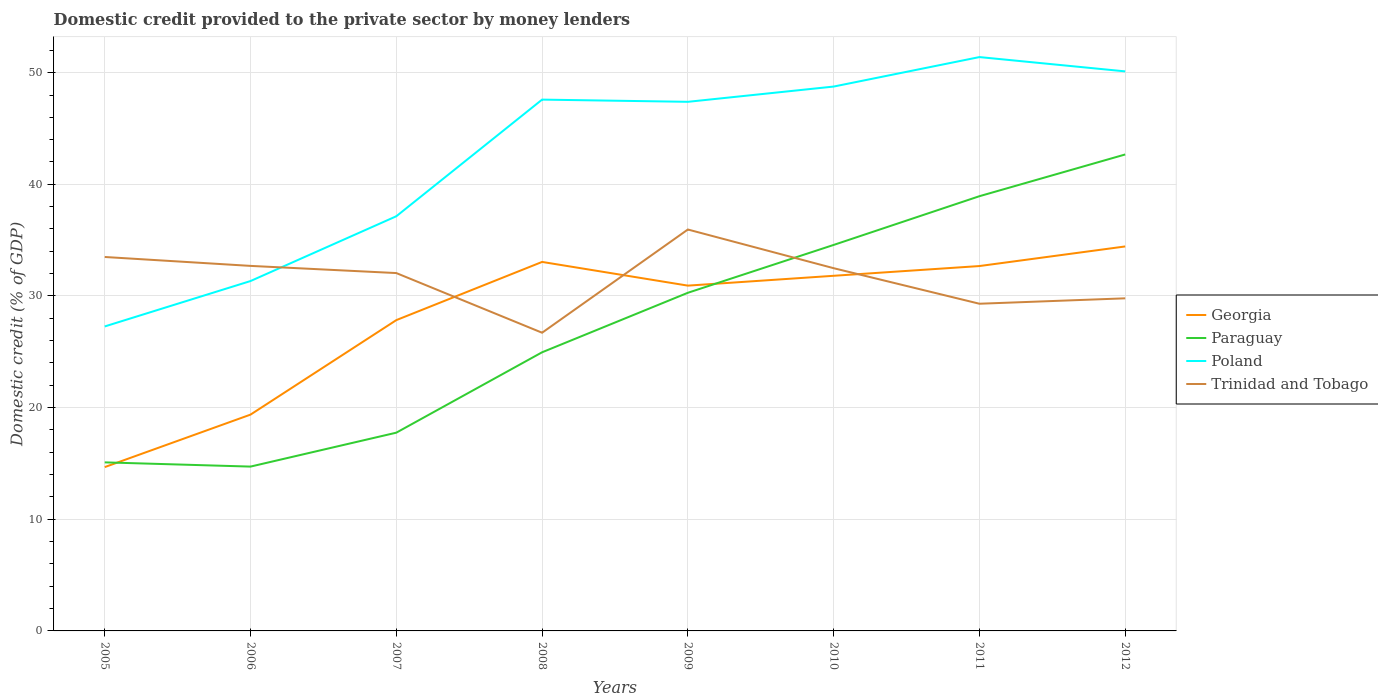How many different coloured lines are there?
Keep it short and to the point. 4. Does the line corresponding to Poland intersect with the line corresponding to Paraguay?
Provide a succinct answer. No. Across all years, what is the maximum domestic credit provided to the private sector by money lenders in Poland?
Make the answer very short. 27.27. In which year was the domestic credit provided to the private sector by money lenders in Georgia maximum?
Ensure brevity in your answer.  2005. What is the total domestic credit provided to the private sector by money lenders in Paraguay in the graph?
Your answer should be compact. -4.29. What is the difference between the highest and the second highest domestic credit provided to the private sector by money lenders in Trinidad and Tobago?
Ensure brevity in your answer.  9.25. Is the domestic credit provided to the private sector by money lenders in Poland strictly greater than the domestic credit provided to the private sector by money lenders in Trinidad and Tobago over the years?
Make the answer very short. No. How many lines are there?
Offer a very short reply. 4. Does the graph contain any zero values?
Ensure brevity in your answer.  No. How are the legend labels stacked?
Ensure brevity in your answer.  Vertical. What is the title of the graph?
Provide a succinct answer. Domestic credit provided to the private sector by money lenders. Does "Dominican Republic" appear as one of the legend labels in the graph?
Ensure brevity in your answer.  No. What is the label or title of the Y-axis?
Ensure brevity in your answer.  Domestic credit (% of GDP). What is the Domestic credit (% of GDP) of Georgia in 2005?
Provide a short and direct response. 14.67. What is the Domestic credit (% of GDP) of Paraguay in 2005?
Your answer should be compact. 15.1. What is the Domestic credit (% of GDP) of Poland in 2005?
Provide a succinct answer. 27.27. What is the Domestic credit (% of GDP) in Trinidad and Tobago in 2005?
Make the answer very short. 33.49. What is the Domestic credit (% of GDP) of Georgia in 2006?
Offer a very short reply. 19.37. What is the Domestic credit (% of GDP) of Paraguay in 2006?
Make the answer very short. 14.72. What is the Domestic credit (% of GDP) in Poland in 2006?
Offer a terse response. 31.34. What is the Domestic credit (% of GDP) of Trinidad and Tobago in 2006?
Provide a short and direct response. 32.7. What is the Domestic credit (% of GDP) in Georgia in 2007?
Make the answer very short. 27.84. What is the Domestic credit (% of GDP) in Paraguay in 2007?
Provide a short and direct response. 17.76. What is the Domestic credit (% of GDP) of Poland in 2007?
Give a very brief answer. 37.14. What is the Domestic credit (% of GDP) of Trinidad and Tobago in 2007?
Your answer should be compact. 32.05. What is the Domestic credit (% of GDP) of Georgia in 2008?
Ensure brevity in your answer.  33.05. What is the Domestic credit (% of GDP) in Paraguay in 2008?
Your response must be concise. 24.96. What is the Domestic credit (% of GDP) in Poland in 2008?
Offer a very short reply. 47.59. What is the Domestic credit (% of GDP) of Trinidad and Tobago in 2008?
Provide a succinct answer. 26.71. What is the Domestic credit (% of GDP) of Georgia in 2009?
Keep it short and to the point. 30.93. What is the Domestic credit (% of GDP) of Paraguay in 2009?
Make the answer very short. 30.29. What is the Domestic credit (% of GDP) of Poland in 2009?
Keep it short and to the point. 47.39. What is the Domestic credit (% of GDP) of Trinidad and Tobago in 2009?
Your answer should be very brief. 35.95. What is the Domestic credit (% of GDP) in Georgia in 2010?
Provide a short and direct response. 31.81. What is the Domestic credit (% of GDP) in Paraguay in 2010?
Give a very brief answer. 34.57. What is the Domestic credit (% of GDP) in Poland in 2010?
Give a very brief answer. 48.76. What is the Domestic credit (% of GDP) of Trinidad and Tobago in 2010?
Your response must be concise. 32.49. What is the Domestic credit (% of GDP) of Georgia in 2011?
Give a very brief answer. 32.68. What is the Domestic credit (% of GDP) in Paraguay in 2011?
Provide a short and direct response. 38.94. What is the Domestic credit (% of GDP) in Poland in 2011?
Give a very brief answer. 51.4. What is the Domestic credit (% of GDP) of Trinidad and Tobago in 2011?
Give a very brief answer. 29.3. What is the Domestic credit (% of GDP) of Georgia in 2012?
Offer a terse response. 34.44. What is the Domestic credit (% of GDP) in Paraguay in 2012?
Your answer should be compact. 42.68. What is the Domestic credit (% of GDP) of Poland in 2012?
Provide a succinct answer. 50.12. What is the Domestic credit (% of GDP) in Trinidad and Tobago in 2012?
Offer a terse response. 29.79. Across all years, what is the maximum Domestic credit (% of GDP) of Georgia?
Your answer should be compact. 34.44. Across all years, what is the maximum Domestic credit (% of GDP) of Paraguay?
Your answer should be very brief. 42.68. Across all years, what is the maximum Domestic credit (% of GDP) of Poland?
Make the answer very short. 51.4. Across all years, what is the maximum Domestic credit (% of GDP) of Trinidad and Tobago?
Provide a short and direct response. 35.95. Across all years, what is the minimum Domestic credit (% of GDP) in Georgia?
Give a very brief answer. 14.67. Across all years, what is the minimum Domestic credit (% of GDP) in Paraguay?
Provide a short and direct response. 14.72. Across all years, what is the minimum Domestic credit (% of GDP) in Poland?
Offer a terse response. 27.27. Across all years, what is the minimum Domestic credit (% of GDP) in Trinidad and Tobago?
Offer a terse response. 26.71. What is the total Domestic credit (% of GDP) of Georgia in the graph?
Your response must be concise. 224.79. What is the total Domestic credit (% of GDP) in Paraguay in the graph?
Your answer should be compact. 219. What is the total Domestic credit (% of GDP) of Poland in the graph?
Provide a succinct answer. 341. What is the total Domestic credit (% of GDP) in Trinidad and Tobago in the graph?
Make the answer very short. 252.48. What is the difference between the Domestic credit (% of GDP) of Georgia in 2005 and that in 2006?
Your response must be concise. -4.7. What is the difference between the Domestic credit (% of GDP) in Paraguay in 2005 and that in 2006?
Offer a very short reply. 0.38. What is the difference between the Domestic credit (% of GDP) of Poland in 2005 and that in 2006?
Give a very brief answer. -4.07. What is the difference between the Domestic credit (% of GDP) of Trinidad and Tobago in 2005 and that in 2006?
Your answer should be very brief. 0.8. What is the difference between the Domestic credit (% of GDP) of Georgia in 2005 and that in 2007?
Provide a short and direct response. -13.16. What is the difference between the Domestic credit (% of GDP) in Paraguay in 2005 and that in 2007?
Give a very brief answer. -2.66. What is the difference between the Domestic credit (% of GDP) of Poland in 2005 and that in 2007?
Give a very brief answer. -9.87. What is the difference between the Domestic credit (% of GDP) of Trinidad and Tobago in 2005 and that in 2007?
Provide a succinct answer. 1.44. What is the difference between the Domestic credit (% of GDP) of Georgia in 2005 and that in 2008?
Keep it short and to the point. -18.38. What is the difference between the Domestic credit (% of GDP) of Paraguay in 2005 and that in 2008?
Ensure brevity in your answer.  -9.86. What is the difference between the Domestic credit (% of GDP) of Poland in 2005 and that in 2008?
Offer a terse response. -20.32. What is the difference between the Domestic credit (% of GDP) of Trinidad and Tobago in 2005 and that in 2008?
Your answer should be very brief. 6.78. What is the difference between the Domestic credit (% of GDP) of Georgia in 2005 and that in 2009?
Your response must be concise. -16.25. What is the difference between the Domestic credit (% of GDP) in Paraguay in 2005 and that in 2009?
Keep it short and to the point. -15.19. What is the difference between the Domestic credit (% of GDP) of Poland in 2005 and that in 2009?
Ensure brevity in your answer.  -20.12. What is the difference between the Domestic credit (% of GDP) of Trinidad and Tobago in 2005 and that in 2009?
Provide a short and direct response. -2.46. What is the difference between the Domestic credit (% of GDP) of Georgia in 2005 and that in 2010?
Offer a very short reply. -17.13. What is the difference between the Domestic credit (% of GDP) in Paraguay in 2005 and that in 2010?
Offer a very short reply. -19.48. What is the difference between the Domestic credit (% of GDP) in Poland in 2005 and that in 2010?
Make the answer very short. -21.49. What is the difference between the Domestic credit (% of GDP) in Trinidad and Tobago in 2005 and that in 2010?
Offer a very short reply. 1. What is the difference between the Domestic credit (% of GDP) in Georgia in 2005 and that in 2011?
Your answer should be compact. -18.01. What is the difference between the Domestic credit (% of GDP) in Paraguay in 2005 and that in 2011?
Provide a short and direct response. -23.84. What is the difference between the Domestic credit (% of GDP) in Poland in 2005 and that in 2011?
Make the answer very short. -24.13. What is the difference between the Domestic credit (% of GDP) in Trinidad and Tobago in 2005 and that in 2011?
Make the answer very short. 4.19. What is the difference between the Domestic credit (% of GDP) in Georgia in 2005 and that in 2012?
Provide a short and direct response. -19.76. What is the difference between the Domestic credit (% of GDP) of Paraguay in 2005 and that in 2012?
Your answer should be compact. -27.58. What is the difference between the Domestic credit (% of GDP) of Poland in 2005 and that in 2012?
Your answer should be compact. -22.85. What is the difference between the Domestic credit (% of GDP) of Trinidad and Tobago in 2005 and that in 2012?
Your answer should be compact. 3.7. What is the difference between the Domestic credit (% of GDP) of Georgia in 2006 and that in 2007?
Offer a terse response. -8.46. What is the difference between the Domestic credit (% of GDP) of Paraguay in 2006 and that in 2007?
Your response must be concise. -3.04. What is the difference between the Domestic credit (% of GDP) in Poland in 2006 and that in 2007?
Your response must be concise. -5.8. What is the difference between the Domestic credit (% of GDP) of Trinidad and Tobago in 2006 and that in 2007?
Make the answer very short. 0.64. What is the difference between the Domestic credit (% of GDP) in Georgia in 2006 and that in 2008?
Offer a very short reply. -13.68. What is the difference between the Domestic credit (% of GDP) in Paraguay in 2006 and that in 2008?
Give a very brief answer. -10.24. What is the difference between the Domestic credit (% of GDP) of Poland in 2006 and that in 2008?
Make the answer very short. -16.25. What is the difference between the Domestic credit (% of GDP) in Trinidad and Tobago in 2006 and that in 2008?
Offer a terse response. 5.99. What is the difference between the Domestic credit (% of GDP) in Georgia in 2006 and that in 2009?
Provide a short and direct response. -11.55. What is the difference between the Domestic credit (% of GDP) of Paraguay in 2006 and that in 2009?
Your answer should be very brief. -15.57. What is the difference between the Domestic credit (% of GDP) of Poland in 2006 and that in 2009?
Give a very brief answer. -16.05. What is the difference between the Domestic credit (% of GDP) of Trinidad and Tobago in 2006 and that in 2009?
Ensure brevity in your answer.  -3.26. What is the difference between the Domestic credit (% of GDP) in Georgia in 2006 and that in 2010?
Provide a succinct answer. -12.43. What is the difference between the Domestic credit (% of GDP) of Paraguay in 2006 and that in 2010?
Your answer should be compact. -19.85. What is the difference between the Domestic credit (% of GDP) of Poland in 2006 and that in 2010?
Provide a short and direct response. -17.42. What is the difference between the Domestic credit (% of GDP) of Trinidad and Tobago in 2006 and that in 2010?
Make the answer very short. 0.21. What is the difference between the Domestic credit (% of GDP) in Georgia in 2006 and that in 2011?
Offer a very short reply. -13.31. What is the difference between the Domestic credit (% of GDP) of Paraguay in 2006 and that in 2011?
Offer a terse response. -24.22. What is the difference between the Domestic credit (% of GDP) of Poland in 2006 and that in 2011?
Provide a succinct answer. -20.06. What is the difference between the Domestic credit (% of GDP) in Trinidad and Tobago in 2006 and that in 2011?
Offer a very short reply. 3.39. What is the difference between the Domestic credit (% of GDP) of Georgia in 2006 and that in 2012?
Give a very brief answer. -15.06. What is the difference between the Domestic credit (% of GDP) in Paraguay in 2006 and that in 2012?
Your response must be concise. -27.96. What is the difference between the Domestic credit (% of GDP) in Poland in 2006 and that in 2012?
Your response must be concise. -18.78. What is the difference between the Domestic credit (% of GDP) of Trinidad and Tobago in 2006 and that in 2012?
Keep it short and to the point. 2.9. What is the difference between the Domestic credit (% of GDP) in Georgia in 2007 and that in 2008?
Make the answer very short. -5.21. What is the difference between the Domestic credit (% of GDP) of Paraguay in 2007 and that in 2008?
Keep it short and to the point. -7.2. What is the difference between the Domestic credit (% of GDP) of Poland in 2007 and that in 2008?
Make the answer very short. -10.45. What is the difference between the Domestic credit (% of GDP) of Trinidad and Tobago in 2007 and that in 2008?
Ensure brevity in your answer.  5.34. What is the difference between the Domestic credit (% of GDP) in Georgia in 2007 and that in 2009?
Offer a very short reply. -3.09. What is the difference between the Domestic credit (% of GDP) of Paraguay in 2007 and that in 2009?
Give a very brief answer. -12.53. What is the difference between the Domestic credit (% of GDP) in Poland in 2007 and that in 2009?
Provide a short and direct response. -10.25. What is the difference between the Domestic credit (% of GDP) of Trinidad and Tobago in 2007 and that in 2009?
Offer a terse response. -3.9. What is the difference between the Domestic credit (% of GDP) in Georgia in 2007 and that in 2010?
Provide a succinct answer. -3.97. What is the difference between the Domestic credit (% of GDP) in Paraguay in 2007 and that in 2010?
Provide a succinct answer. -16.82. What is the difference between the Domestic credit (% of GDP) in Poland in 2007 and that in 2010?
Your answer should be very brief. -11.62. What is the difference between the Domestic credit (% of GDP) of Trinidad and Tobago in 2007 and that in 2010?
Provide a succinct answer. -0.44. What is the difference between the Domestic credit (% of GDP) in Georgia in 2007 and that in 2011?
Your answer should be compact. -4.84. What is the difference between the Domestic credit (% of GDP) of Paraguay in 2007 and that in 2011?
Your response must be concise. -21.18. What is the difference between the Domestic credit (% of GDP) of Poland in 2007 and that in 2011?
Offer a very short reply. -14.26. What is the difference between the Domestic credit (% of GDP) in Trinidad and Tobago in 2007 and that in 2011?
Keep it short and to the point. 2.75. What is the difference between the Domestic credit (% of GDP) in Georgia in 2007 and that in 2012?
Provide a succinct answer. -6.6. What is the difference between the Domestic credit (% of GDP) of Paraguay in 2007 and that in 2012?
Provide a succinct answer. -24.92. What is the difference between the Domestic credit (% of GDP) in Poland in 2007 and that in 2012?
Keep it short and to the point. -12.98. What is the difference between the Domestic credit (% of GDP) in Trinidad and Tobago in 2007 and that in 2012?
Provide a short and direct response. 2.26. What is the difference between the Domestic credit (% of GDP) of Georgia in 2008 and that in 2009?
Provide a succinct answer. 2.12. What is the difference between the Domestic credit (% of GDP) of Paraguay in 2008 and that in 2009?
Your response must be concise. -5.33. What is the difference between the Domestic credit (% of GDP) in Poland in 2008 and that in 2009?
Offer a terse response. 0.2. What is the difference between the Domestic credit (% of GDP) in Trinidad and Tobago in 2008 and that in 2009?
Provide a succinct answer. -9.25. What is the difference between the Domestic credit (% of GDP) of Georgia in 2008 and that in 2010?
Make the answer very short. 1.24. What is the difference between the Domestic credit (% of GDP) of Paraguay in 2008 and that in 2010?
Offer a very short reply. -9.62. What is the difference between the Domestic credit (% of GDP) of Poland in 2008 and that in 2010?
Your answer should be compact. -1.17. What is the difference between the Domestic credit (% of GDP) of Trinidad and Tobago in 2008 and that in 2010?
Provide a short and direct response. -5.78. What is the difference between the Domestic credit (% of GDP) of Georgia in 2008 and that in 2011?
Keep it short and to the point. 0.37. What is the difference between the Domestic credit (% of GDP) in Paraguay in 2008 and that in 2011?
Ensure brevity in your answer.  -13.98. What is the difference between the Domestic credit (% of GDP) in Poland in 2008 and that in 2011?
Keep it short and to the point. -3.81. What is the difference between the Domestic credit (% of GDP) of Trinidad and Tobago in 2008 and that in 2011?
Offer a very short reply. -2.6. What is the difference between the Domestic credit (% of GDP) in Georgia in 2008 and that in 2012?
Keep it short and to the point. -1.39. What is the difference between the Domestic credit (% of GDP) in Paraguay in 2008 and that in 2012?
Give a very brief answer. -17.72. What is the difference between the Domestic credit (% of GDP) in Poland in 2008 and that in 2012?
Ensure brevity in your answer.  -2.53. What is the difference between the Domestic credit (% of GDP) in Trinidad and Tobago in 2008 and that in 2012?
Ensure brevity in your answer.  -3.08. What is the difference between the Domestic credit (% of GDP) in Georgia in 2009 and that in 2010?
Keep it short and to the point. -0.88. What is the difference between the Domestic credit (% of GDP) of Paraguay in 2009 and that in 2010?
Your response must be concise. -4.29. What is the difference between the Domestic credit (% of GDP) of Poland in 2009 and that in 2010?
Offer a very short reply. -1.37. What is the difference between the Domestic credit (% of GDP) in Trinidad and Tobago in 2009 and that in 2010?
Keep it short and to the point. 3.47. What is the difference between the Domestic credit (% of GDP) in Georgia in 2009 and that in 2011?
Give a very brief answer. -1.75. What is the difference between the Domestic credit (% of GDP) in Paraguay in 2009 and that in 2011?
Offer a very short reply. -8.65. What is the difference between the Domestic credit (% of GDP) of Poland in 2009 and that in 2011?
Your answer should be compact. -4.01. What is the difference between the Domestic credit (% of GDP) in Trinidad and Tobago in 2009 and that in 2011?
Ensure brevity in your answer.  6.65. What is the difference between the Domestic credit (% of GDP) of Georgia in 2009 and that in 2012?
Offer a terse response. -3.51. What is the difference between the Domestic credit (% of GDP) in Paraguay in 2009 and that in 2012?
Ensure brevity in your answer.  -12.39. What is the difference between the Domestic credit (% of GDP) of Poland in 2009 and that in 2012?
Your answer should be compact. -2.73. What is the difference between the Domestic credit (% of GDP) of Trinidad and Tobago in 2009 and that in 2012?
Your response must be concise. 6.16. What is the difference between the Domestic credit (% of GDP) of Georgia in 2010 and that in 2011?
Make the answer very short. -0.87. What is the difference between the Domestic credit (% of GDP) in Paraguay in 2010 and that in 2011?
Ensure brevity in your answer.  -4.37. What is the difference between the Domestic credit (% of GDP) in Poland in 2010 and that in 2011?
Keep it short and to the point. -2.64. What is the difference between the Domestic credit (% of GDP) of Trinidad and Tobago in 2010 and that in 2011?
Your response must be concise. 3.18. What is the difference between the Domestic credit (% of GDP) of Georgia in 2010 and that in 2012?
Your response must be concise. -2.63. What is the difference between the Domestic credit (% of GDP) in Paraguay in 2010 and that in 2012?
Provide a short and direct response. -8.1. What is the difference between the Domestic credit (% of GDP) in Poland in 2010 and that in 2012?
Your response must be concise. -1.36. What is the difference between the Domestic credit (% of GDP) of Trinidad and Tobago in 2010 and that in 2012?
Your answer should be compact. 2.7. What is the difference between the Domestic credit (% of GDP) of Georgia in 2011 and that in 2012?
Provide a succinct answer. -1.76. What is the difference between the Domestic credit (% of GDP) of Paraguay in 2011 and that in 2012?
Make the answer very short. -3.74. What is the difference between the Domestic credit (% of GDP) of Poland in 2011 and that in 2012?
Keep it short and to the point. 1.28. What is the difference between the Domestic credit (% of GDP) in Trinidad and Tobago in 2011 and that in 2012?
Your answer should be compact. -0.49. What is the difference between the Domestic credit (% of GDP) in Georgia in 2005 and the Domestic credit (% of GDP) in Paraguay in 2006?
Offer a terse response. -0.05. What is the difference between the Domestic credit (% of GDP) of Georgia in 2005 and the Domestic credit (% of GDP) of Poland in 2006?
Give a very brief answer. -16.66. What is the difference between the Domestic credit (% of GDP) in Georgia in 2005 and the Domestic credit (% of GDP) in Trinidad and Tobago in 2006?
Offer a terse response. -18.02. What is the difference between the Domestic credit (% of GDP) of Paraguay in 2005 and the Domestic credit (% of GDP) of Poland in 2006?
Make the answer very short. -16.24. What is the difference between the Domestic credit (% of GDP) of Paraguay in 2005 and the Domestic credit (% of GDP) of Trinidad and Tobago in 2006?
Provide a short and direct response. -17.6. What is the difference between the Domestic credit (% of GDP) in Poland in 2005 and the Domestic credit (% of GDP) in Trinidad and Tobago in 2006?
Offer a terse response. -5.42. What is the difference between the Domestic credit (% of GDP) of Georgia in 2005 and the Domestic credit (% of GDP) of Paraguay in 2007?
Make the answer very short. -3.08. What is the difference between the Domestic credit (% of GDP) in Georgia in 2005 and the Domestic credit (% of GDP) in Poland in 2007?
Your answer should be compact. -22.47. What is the difference between the Domestic credit (% of GDP) of Georgia in 2005 and the Domestic credit (% of GDP) of Trinidad and Tobago in 2007?
Offer a very short reply. -17.38. What is the difference between the Domestic credit (% of GDP) of Paraguay in 2005 and the Domestic credit (% of GDP) of Poland in 2007?
Make the answer very short. -22.04. What is the difference between the Domestic credit (% of GDP) of Paraguay in 2005 and the Domestic credit (% of GDP) of Trinidad and Tobago in 2007?
Keep it short and to the point. -16.96. What is the difference between the Domestic credit (% of GDP) in Poland in 2005 and the Domestic credit (% of GDP) in Trinidad and Tobago in 2007?
Your answer should be compact. -4.78. What is the difference between the Domestic credit (% of GDP) of Georgia in 2005 and the Domestic credit (% of GDP) of Paraguay in 2008?
Keep it short and to the point. -10.28. What is the difference between the Domestic credit (% of GDP) in Georgia in 2005 and the Domestic credit (% of GDP) in Poland in 2008?
Offer a terse response. -32.91. What is the difference between the Domestic credit (% of GDP) in Georgia in 2005 and the Domestic credit (% of GDP) in Trinidad and Tobago in 2008?
Offer a very short reply. -12.03. What is the difference between the Domestic credit (% of GDP) in Paraguay in 2005 and the Domestic credit (% of GDP) in Poland in 2008?
Ensure brevity in your answer.  -32.49. What is the difference between the Domestic credit (% of GDP) in Paraguay in 2005 and the Domestic credit (% of GDP) in Trinidad and Tobago in 2008?
Give a very brief answer. -11.61. What is the difference between the Domestic credit (% of GDP) of Poland in 2005 and the Domestic credit (% of GDP) of Trinidad and Tobago in 2008?
Make the answer very short. 0.56. What is the difference between the Domestic credit (% of GDP) in Georgia in 2005 and the Domestic credit (% of GDP) in Paraguay in 2009?
Your answer should be very brief. -15.61. What is the difference between the Domestic credit (% of GDP) in Georgia in 2005 and the Domestic credit (% of GDP) in Poland in 2009?
Your answer should be compact. -32.72. What is the difference between the Domestic credit (% of GDP) in Georgia in 2005 and the Domestic credit (% of GDP) in Trinidad and Tobago in 2009?
Ensure brevity in your answer.  -21.28. What is the difference between the Domestic credit (% of GDP) of Paraguay in 2005 and the Domestic credit (% of GDP) of Poland in 2009?
Keep it short and to the point. -32.29. What is the difference between the Domestic credit (% of GDP) in Paraguay in 2005 and the Domestic credit (% of GDP) in Trinidad and Tobago in 2009?
Your answer should be very brief. -20.86. What is the difference between the Domestic credit (% of GDP) of Poland in 2005 and the Domestic credit (% of GDP) of Trinidad and Tobago in 2009?
Give a very brief answer. -8.68. What is the difference between the Domestic credit (% of GDP) in Georgia in 2005 and the Domestic credit (% of GDP) in Paraguay in 2010?
Keep it short and to the point. -19.9. What is the difference between the Domestic credit (% of GDP) of Georgia in 2005 and the Domestic credit (% of GDP) of Poland in 2010?
Provide a short and direct response. -34.08. What is the difference between the Domestic credit (% of GDP) of Georgia in 2005 and the Domestic credit (% of GDP) of Trinidad and Tobago in 2010?
Give a very brief answer. -17.81. What is the difference between the Domestic credit (% of GDP) of Paraguay in 2005 and the Domestic credit (% of GDP) of Poland in 2010?
Make the answer very short. -33.66. What is the difference between the Domestic credit (% of GDP) in Paraguay in 2005 and the Domestic credit (% of GDP) in Trinidad and Tobago in 2010?
Keep it short and to the point. -17.39. What is the difference between the Domestic credit (% of GDP) of Poland in 2005 and the Domestic credit (% of GDP) of Trinidad and Tobago in 2010?
Ensure brevity in your answer.  -5.22. What is the difference between the Domestic credit (% of GDP) in Georgia in 2005 and the Domestic credit (% of GDP) in Paraguay in 2011?
Keep it short and to the point. -24.26. What is the difference between the Domestic credit (% of GDP) in Georgia in 2005 and the Domestic credit (% of GDP) in Poland in 2011?
Provide a short and direct response. -36.72. What is the difference between the Domestic credit (% of GDP) in Georgia in 2005 and the Domestic credit (% of GDP) in Trinidad and Tobago in 2011?
Your response must be concise. -14.63. What is the difference between the Domestic credit (% of GDP) of Paraguay in 2005 and the Domestic credit (% of GDP) of Poland in 2011?
Ensure brevity in your answer.  -36.3. What is the difference between the Domestic credit (% of GDP) of Paraguay in 2005 and the Domestic credit (% of GDP) of Trinidad and Tobago in 2011?
Your answer should be compact. -14.21. What is the difference between the Domestic credit (% of GDP) in Poland in 2005 and the Domestic credit (% of GDP) in Trinidad and Tobago in 2011?
Give a very brief answer. -2.03. What is the difference between the Domestic credit (% of GDP) in Georgia in 2005 and the Domestic credit (% of GDP) in Paraguay in 2012?
Give a very brief answer. -28. What is the difference between the Domestic credit (% of GDP) in Georgia in 2005 and the Domestic credit (% of GDP) in Poland in 2012?
Your response must be concise. -35.44. What is the difference between the Domestic credit (% of GDP) of Georgia in 2005 and the Domestic credit (% of GDP) of Trinidad and Tobago in 2012?
Offer a very short reply. -15.12. What is the difference between the Domestic credit (% of GDP) of Paraguay in 2005 and the Domestic credit (% of GDP) of Poland in 2012?
Ensure brevity in your answer.  -35.02. What is the difference between the Domestic credit (% of GDP) of Paraguay in 2005 and the Domestic credit (% of GDP) of Trinidad and Tobago in 2012?
Keep it short and to the point. -14.69. What is the difference between the Domestic credit (% of GDP) of Poland in 2005 and the Domestic credit (% of GDP) of Trinidad and Tobago in 2012?
Your answer should be compact. -2.52. What is the difference between the Domestic credit (% of GDP) in Georgia in 2006 and the Domestic credit (% of GDP) in Paraguay in 2007?
Your response must be concise. 1.62. What is the difference between the Domestic credit (% of GDP) of Georgia in 2006 and the Domestic credit (% of GDP) of Poland in 2007?
Ensure brevity in your answer.  -17.77. What is the difference between the Domestic credit (% of GDP) in Georgia in 2006 and the Domestic credit (% of GDP) in Trinidad and Tobago in 2007?
Offer a terse response. -12.68. What is the difference between the Domestic credit (% of GDP) in Paraguay in 2006 and the Domestic credit (% of GDP) in Poland in 2007?
Offer a very short reply. -22.42. What is the difference between the Domestic credit (% of GDP) in Paraguay in 2006 and the Domestic credit (% of GDP) in Trinidad and Tobago in 2007?
Provide a short and direct response. -17.33. What is the difference between the Domestic credit (% of GDP) of Poland in 2006 and the Domestic credit (% of GDP) of Trinidad and Tobago in 2007?
Provide a short and direct response. -0.72. What is the difference between the Domestic credit (% of GDP) in Georgia in 2006 and the Domestic credit (% of GDP) in Paraguay in 2008?
Make the answer very short. -5.58. What is the difference between the Domestic credit (% of GDP) of Georgia in 2006 and the Domestic credit (% of GDP) of Poland in 2008?
Your response must be concise. -28.21. What is the difference between the Domestic credit (% of GDP) in Georgia in 2006 and the Domestic credit (% of GDP) in Trinidad and Tobago in 2008?
Offer a very short reply. -7.33. What is the difference between the Domestic credit (% of GDP) of Paraguay in 2006 and the Domestic credit (% of GDP) of Poland in 2008?
Your answer should be compact. -32.87. What is the difference between the Domestic credit (% of GDP) in Paraguay in 2006 and the Domestic credit (% of GDP) in Trinidad and Tobago in 2008?
Give a very brief answer. -11.99. What is the difference between the Domestic credit (% of GDP) in Poland in 2006 and the Domestic credit (% of GDP) in Trinidad and Tobago in 2008?
Make the answer very short. 4.63. What is the difference between the Domestic credit (% of GDP) of Georgia in 2006 and the Domestic credit (% of GDP) of Paraguay in 2009?
Offer a terse response. -10.91. What is the difference between the Domestic credit (% of GDP) in Georgia in 2006 and the Domestic credit (% of GDP) in Poland in 2009?
Your response must be concise. -28.02. What is the difference between the Domestic credit (% of GDP) of Georgia in 2006 and the Domestic credit (% of GDP) of Trinidad and Tobago in 2009?
Your response must be concise. -16.58. What is the difference between the Domestic credit (% of GDP) in Paraguay in 2006 and the Domestic credit (% of GDP) in Poland in 2009?
Ensure brevity in your answer.  -32.67. What is the difference between the Domestic credit (% of GDP) of Paraguay in 2006 and the Domestic credit (% of GDP) of Trinidad and Tobago in 2009?
Give a very brief answer. -21.23. What is the difference between the Domestic credit (% of GDP) in Poland in 2006 and the Domestic credit (% of GDP) in Trinidad and Tobago in 2009?
Make the answer very short. -4.62. What is the difference between the Domestic credit (% of GDP) in Georgia in 2006 and the Domestic credit (% of GDP) in Paraguay in 2010?
Give a very brief answer. -15.2. What is the difference between the Domestic credit (% of GDP) in Georgia in 2006 and the Domestic credit (% of GDP) in Poland in 2010?
Your answer should be compact. -29.38. What is the difference between the Domestic credit (% of GDP) of Georgia in 2006 and the Domestic credit (% of GDP) of Trinidad and Tobago in 2010?
Provide a short and direct response. -13.11. What is the difference between the Domestic credit (% of GDP) of Paraguay in 2006 and the Domestic credit (% of GDP) of Poland in 2010?
Your response must be concise. -34.04. What is the difference between the Domestic credit (% of GDP) in Paraguay in 2006 and the Domestic credit (% of GDP) in Trinidad and Tobago in 2010?
Give a very brief answer. -17.77. What is the difference between the Domestic credit (% of GDP) of Poland in 2006 and the Domestic credit (% of GDP) of Trinidad and Tobago in 2010?
Ensure brevity in your answer.  -1.15. What is the difference between the Domestic credit (% of GDP) in Georgia in 2006 and the Domestic credit (% of GDP) in Paraguay in 2011?
Your answer should be compact. -19.56. What is the difference between the Domestic credit (% of GDP) of Georgia in 2006 and the Domestic credit (% of GDP) of Poland in 2011?
Offer a terse response. -32.02. What is the difference between the Domestic credit (% of GDP) in Georgia in 2006 and the Domestic credit (% of GDP) in Trinidad and Tobago in 2011?
Your answer should be compact. -9.93. What is the difference between the Domestic credit (% of GDP) of Paraguay in 2006 and the Domestic credit (% of GDP) of Poland in 2011?
Your answer should be very brief. -36.68. What is the difference between the Domestic credit (% of GDP) in Paraguay in 2006 and the Domestic credit (% of GDP) in Trinidad and Tobago in 2011?
Provide a short and direct response. -14.59. What is the difference between the Domestic credit (% of GDP) in Poland in 2006 and the Domestic credit (% of GDP) in Trinidad and Tobago in 2011?
Offer a very short reply. 2.03. What is the difference between the Domestic credit (% of GDP) in Georgia in 2006 and the Domestic credit (% of GDP) in Paraguay in 2012?
Ensure brevity in your answer.  -23.3. What is the difference between the Domestic credit (% of GDP) in Georgia in 2006 and the Domestic credit (% of GDP) in Poland in 2012?
Ensure brevity in your answer.  -30.74. What is the difference between the Domestic credit (% of GDP) in Georgia in 2006 and the Domestic credit (% of GDP) in Trinidad and Tobago in 2012?
Offer a very short reply. -10.42. What is the difference between the Domestic credit (% of GDP) in Paraguay in 2006 and the Domestic credit (% of GDP) in Poland in 2012?
Your response must be concise. -35.4. What is the difference between the Domestic credit (% of GDP) in Paraguay in 2006 and the Domestic credit (% of GDP) in Trinidad and Tobago in 2012?
Ensure brevity in your answer.  -15.07. What is the difference between the Domestic credit (% of GDP) in Poland in 2006 and the Domestic credit (% of GDP) in Trinidad and Tobago in 2012?
Give a very brief answer. 1.55. What is the difference between the Domestic credit (% of GDP) of Georgia in 2007 and the Domestic credit (% of GDP) of Paraguay in 2008?
Provide a succinct answer. 2.88. What is the difference between the Domestic credit (% of GDP) of Georgia in 2007 and the Domestic credit (% of GDP) of Poland in 2008?
Ensure brevity in your answer.  -19.75. What is the difference between the Domestic credit (% of GDP) of Georgia in 2007 and the Domestic credit (% of GDP) of Trinidad and Tobago in 2008?
Offer a terse response. 1.13. What is the difference between the Domestic credit (% of GDP) of Paraguay in 2007 and the Domestic credit (% of GDP) of Poland in 2008?
Give a very brief answer. -29.83. What is the difference between the Domestic credit (% of GDP) of Paraguay in 2007 and the Domestic credit (% of GDP) of Trinidad and Tobago in 2008?
Your answer should be very brief. -8.95. What is the difference between the Domestic credit (% of GDP) in Poland in 2007 and the Domestic credit (% of GDP) in Trinidad and Tobago in 2008?
Give a very brief answer. 10.43. What is the difference between the Domestic credit (% of GDP) of Georgia in 2007 and the Domestic credit (% of GDP) of Paraguay in 2009?
Offer a very short reply. -2.45. What is the difference between the Domestic credit (% of GDP) in Georgia in 2007 and the Domestic credit (% of GDP) in Poland in 2009?
Make the answer very short. -19.55. What is the difference between the Domestic credit (% of GDP) in Georgia in 2007 and the Domestic credit (% of GDP) in Trinidad and Tobago in 2009?
Offer a terse response. -8.12. What is the difference between the Domestic credit (% of GDP) of Paraguay in 2007 and the Domestic credit (% of GDP) of Poland in 2009?
Provide a short and direct response. -29.63. What is the difference between the Domestic credit (% of GDP) of Paraguay in 2007 and the Domestic credit (% of GDP) of Trinidad and Tobago in 2009?
Provide a succinct answer. -18.2. What is the difference between the Domestic credit (% of GDP) of Poland in 2007 and the Domestic credit (% of GDP) of Trinidad and Tobago in 2009?
Give a very brief answer. 1.19. What is the difference between the Domestic credit (% of GDP) in Georgia in 2007 and the Domestic credit (% of GDP) in Paraguay in 2010?
Keep it short and to the point. -6.73. What is the difference between the Domestic credit (% of GDP) of Georgia in 2007 and the Domestic credit (% of GDP) of Poland in 2010?
Give a very brief answer. -20.92. What is the difference between the Domestic credit (% of GDP) of Georgia in 2007 and the Domestic credit (% of GDP) of Trinidad and Tobago in 2010?
Offer a very short reply. -4.65. What is the difference between the Domestic credit (% of GDP) in Paraguay in 2007 and the Domestic credit (% of GDP) in Poland in 2010?
Your answer should be very brief. -31. What is the difference between the Domestic credit (% of GDP) of Paraguay in 2007 and the Domestic credit (% of GDP) of Trinidad and Tobago in 2010?
Keep it short and to the point. -14.73. What is the difference between the Domestic credit (% of GDP) of Poland in 2007 and the Domestic credit (% of GDP) of Trinidad and Tobago in 2010?
Your answer should be compact. 4.65. What is the difference between the Domestic credit (% of GDP) of Georgia in 2007 and the Domestic credit (% of GDP) of Paraguay in 2011?
Ensure brevity in your answer.  -11.1. What is the difference between the Domestic credit (% of GDP) of Georgia in 2007 and the Domestic credit (% of GDP) of Poland in 2011?
Provide a short and direct response. -23.56. What is the difference between the Domestic credit (% of GDP) of Georgia in 2007 and the Domestic credit (% of GDP) of Trinidad and Tobago in 2011?
Your answer should be compact. -1.47. What is the difference between the Domestic credit (% of GDP) in Paraguay in 2007 and the Domestic credit (% of GDP) in Poland in 2011?
Keep it short and to the point. -33.64. What is the difference between the Domestic credit (% of GDP) in Paraguay in 2007 and the Domestic credit (% of GDP) in Trinidad and Tobago in 2011?
Offer a terse response. -11.55. What is the difference between the Domestic credit (% of GDP) in Poland in 2007 and the Domestic credit (% of GDP) in Trinidad and Tobago in 2011?
Your response must be concise. 7.84. What is the difference between the Domestic credit (% of GDP) in Georgia in 2007 and the Domestic credit (% of GDP) in Paraguay in 2012?
Give a very brief answer. -14.84. What is the difference between the Domestic credit (% of GDP) of Georgia in 2007 and the Domestic credit (% of GDP) of Poland in 2012?
Provide a succinct answer. -22.28. What is the difference between the Domestic credit (% of GDP) in Georgia in 2007 and the Domestic credit (% of GDP) in Trinidad and Tobago in 2012?
Make the answer very short. -1.95. What is the difference between the Domestic credit (% of GDP) of Paraguay in 2007 and the Domestic credit (% of GDP) of Poland in 2012?
Give a very brief answer. -32.36. What is the difference between the Domestic credit (% of GDP) in Paraguay in 2007 and the Domestic credit (% of GDP) in Trinidad and Tobago in 2012?
Your answer should be very brief. -12.03. What is the difference between the Domestic credit (% of GDP) in Poland in 2007 and the Domestic credit (% of GDP) in Trinidad and Tobago in 2012?
Give a very brief answer. 7.35. What is the difference between the Domestic credit (% of GDP) in Georgia in 2008 and the Domestic credit (% of GDP) in Paraguay in 2009?
Make the answer very short. 2.76. What is the difference between the Domestic credit (% of GDP) of Georgia in 2008 and the Domestic credit (% of GDP) of Poland in 2009?
Ensure brevity in your answer.  -14.34. What is the difference between the Domestic credit (% of GDP) in Georgia in 2008 and the Domestic credit (% of GDP) in Trinidad and Tobago in 2009?
Your answer should be compact. -2.9. What is the difference between the Domestic credit (% of GDP) of Paraguay in 2008 and the Domestic credit (% of GDP) of Poland in 2009?
Your response must be concise. -22.43. What is the difference between the Domestic credit (% of GDP) of Paraguay in 2008 and the Domestic credit (% of GDP) of Trinidad and Tobago in 2009?
Provide a succinct answer. -11. What is the difference between the Domestic credit (% of GDP) of Poland in 2008 and the Domestic credit (% of GDP) of Trinidad and Tobago in 2009?
Ensure brevity in your answer.  11.63. What is the difference between the Domestic credit (% of GDP) of Georgia in 2008 and the Domestic credit (% of GDP) of Paraguay in 2010?
Offer a terse response. -1.52. What is the difference between the Domestic credit (% of GDP) of Georgia in 2008 and the Domestic credit (% of GDP) of Poland in 2010?
Ensure brevity in your answer.  -15.71. What is the difference between the Domestic credit (% of GDP) in Georgia in 2008 and the Domestic credit (% of GDP) in Trinidad and Tobago in 2010?
Your answer should be compact. 0.56. What is the difference between the Domestic credit (% of GDP) of Paraguay in 2008 and the Domestic credit (% of GDP) of Poland in 2010?
Offer a terse response. -23.8. What is the difference between the Domestic credit (% of GDP) of Paraguay in 2008 and the Domestic credit (% of GDP) of Trinidad and Tobago in 2010?
Your answer should be compact. -7.53. What is the difference between the Domestic credit (% of GDP) of Poland in 2008 and the Domestic credit (% of GDP) of Trinidad and Tobago in 2010?
Your response must be concise. 15.1. What is the difference between the Domestic credit (% of GDP) in Georgia in 2008 and the Domestic credit (% of GDP) in Paraguay in 2011?
Provide a short and direct response. -5.89. What is the difference between the Domestic credit (% of GDP) in Georgia in 2008 and the Domestic credit (% of GDP) in Poland in 2011?
Offer a very short reply. -18.35. What is the difference between the Domestic credit (% of GDP) of Georgia in 2008 and the Domestic credit (% of GDP) of Trinidad and Tobago in 2011?
Your answer should be compact. 3.75. What is the difference between the Domestic credit (% of GDP) of Paraguay in 2008 and the Domestic credit (% of GDP) of Poland in 2011?
Make the answer very short. -26.44. What is the difference between the Domestic credit (% of GDP) in Paraguay in 2008 and the Domestic credit (% of GDP) in Trinidad and Tobago in 2011?
Keep it short and to the point. -4.35. What is the difference between the Domestic credit (% of GDP) in Poland in 2008 and the Domestic credit (% of GDP) in Trinidad and Tobago in 2011?
Your answer should be very brief. 18.28. What is the difference between the Domestic credit (% of GDP) of Georgia in 2008 and the Domestic credit (% of GDP) of Paraguay in 2012?
Make the answer very short. -9.62. What is the difference between the Domestic credit (% of GDP) of Georgia in 2008 and the Domestic credit (% of GDP) of Poland in 2012?
Offer a terse response. -17.07. What is the difference between the Domestic credit (% of GDP) of Georgia in 2008 and the Domestic credit (% of GDP) of Trinidad and Tobago in 2012?
Make the answer very short. 3.26. What is the difference between the Domestic credit (% of GDP) of Paraguay in 2008 and the Domestic credit (% of GDP) of Poland in 2012?
Make the answer very short. -25.16. What is the difference between the Domestic credit (% of GDP) of Paraguay in 2008 and the Domestic credit (% of GDP) of Trinidad and Tobago in 2012?
Provide a short and direct response. -4.83. What is the difference between the Domestic credit (% of GDP) of Poland in 2008 and the Domestic credit (% of GDP) of Trinidad and Tobago in 2012?
Provide a succinct answer. 17.8. What is the difference between the Domestic credit (% of GDP) in Georgia in 2009 and the Domestic credit (% of GDP) in Paraguay in 2010?
Give a very brief answer. -3.64. What is the difference between the Domestic credit (% of GDP) in Georgia in 2009 and the Domestic credit (% of GDP) in Poland in 2010?
Give a very brief answer. -17.83. What is the difference between the Domestic credit (% of GDP) in Georgia in 2009 and the Domestic credit (% of GDP) in Trinidad and Tobago in 2010?
Provide a short and direct response. -1.56. What is the difference between the Domestic credit (% of GDP) in Paraguay in 2009 and the Domestic credit (% of GDP) in Poland in 2010?
Your answer should be very brief. -18.47. What is the difference between the Domestic credit (% of GDP) in Paraguay in 2009 and the Domestic credit (% of GDP) in Trinidad and Tobago in 2010?
Your answer should be very brief. -2.2. What is the difference between the Domestic credit (% of GDP) of Poland in 2009 and the Domestic credit (% of GDP) of Trinidad and Tobago in 2010?
Your answer should be very brief. 14.9. What is the difference between the Domestic credit (% of GDP) of Georgia in 2009 and the Domestic credit (% of GDP) of Paraguay in 2011?
Make the answer very short. -8.01. What is the difference between the Domestic credit (% of GDP) of Georgia in 2009 and the Domestic credit (% of GDP) of Poland in 2011?
Your answer should be compact. -20.47. What is the difference between the Domestic credit (% of GDP) of Georgia in 2009 and the Domestic credit (% of GDP) of Trinidad and Tobago in 2011?
Your answer should be compact. 1.62. What is the difference between the Domestic credit (% of GDP) of Paraguay in 2009 and the Domestic credit (% of GDP) of Poland in 2011?
Give a very brief answer. -21.11. What is the difference between the Domestic credit (% of GDP) in Paraguay in 2009 and the Domestic credit (% of GDP) in Trinidad and Tobago in 2011?
Make the answer very short. 0.98. What is the difference between the Domestic credit (% of GDP) in Poland in 2009 and the Domestic credit (% of GDP) in Trinidad and Tobago in 2011?
Your response must be concise. 18.09. What is the difference between the Domestic credit (% of GDP) in Georgia in 2009 and the Domestic credit (% of GDP) in Paraguay in 2012?
Your response must be concise. -11.75. What is the difference between the Domestic credit (% of GDP) of Georgia in 2009 and the Domestic credit (% of GDP) of Poland in 2012?
Make the answer very short. -19.19. What is the difference between the Domestic credit (% of GDP) of Georgia in 2009 and the Domestic credit (% of GDP) of Trinidad and Tobago in 2012?
Your answer should be compact. 1.14. What is the difference between the Domestic credit (% of GDP) in Paraguay in 2009 and the Domestic credit (% of GDP) in Poland in 2012?
Your answer should be compact. -19.83. What is the difference between the Domestic credit (% of GDP) of Paraguay in 2009 and the Domestic credit (% of GDP) of Trinidad and Tobago in 2012?
Make the answer very short. 0.5. What is the difference between the Domestic credit (% of GDP) of Poland in 2009 and the Domestic credit (% of GDP) of Trinidad and Tobago in 2012?
Give a very brief answer. 17.6. What is the difference between the Domestic credit (% of GDP) of Georgia in 2010 and the Domestic credit (% of GDP) of Paraguay in 2011?
Offer a terse response. -7.13. What is the difference between the Domestic credit (% of GDP) in Georgia in 2010 and the Domestic credit (% of GDP) in Poland in 2011?
Keep it short and to the point. -19.59. What is the difference between the Domestic credit (% of GDP) of Georgia in 2010 and the Domestic credit (% of GDP) of Trinidad and Tobago in 2011?
Your response must be concise. 2.5. What is the difference between the Domestic credit (% of GDP) in Paraguay in 2010 and the Domestic credit (% of GDP) in Poland in 2011?
Offer a very short reply. -16.83. What is the difference between the Domestic credit (% of GDP) of Paraguay in 2010 and the Domestic credit (% of GDP) of Trinidad and Tobago in 2011?
Offer a terse response. 5.27. What is the difference between the Domestic credit (% of GDP) in Poland in 2010 and the Domestic credit (% of GDP) in Trinidad and Tobago in 2011?
Provide a short and direct response. 19.45. What is the difference between the Domestic credit (% of GDP) of Georgia in 2010 and the Domestic credit (% of GDP) of Paraguay in 2012?
Offer a very short reply. -10.87. What is the difference between the Domestic credit (% of GDP) of Georgia in 2010 and the Domestic credit (% of GDP) of Poland in 2012?
Provide a short and direct response. -18.31. What is the difference between the Domestic credit (% of GDP) of Georgia in 2010 and the Domestic credit (% of GDP) of Trinidad and Tobago in 2012?
Offer a terse response. 2.02. What is the difference between the Domestic credit (% of GDP) in Paraguay in 2010 and the Domestic credit (% of GDP) in Poland in 2012?
Make the answer very short. -15.54. What is the difference between the Domestic credit (% of GDP) of Paraguay in 2010 and the Domestic credit (% of GDP) of Trinidad and Tobago in 2012?
Give a very brief answer. 4.78. What is the difference between the Domestic credit (% of GDP) in Poland in 2010 and the Domestic credit (% of GDP) in Trinidad and Tobago in 2012?
Keep it short and to the point. 18.97. What is the difference between the Domestic credit (% of GDP) in Georgia in 2011 and the Domestic credit (% of GDP) in Paraguay in 2012?
Make the answer very short. -9.99. What is the difference between the Domestic credit (% of GDP) in Georgia in 2011 and the Domestic credit (% of GDP) in Poland in 2012?
Your response must be concise. -17.44. What is the difference between the Domestic credit (% of GDP) in Georgia in 2011 and the Domestic credit (% of GDP) in Trinidad and Tobago in 2012?
Provide a succinct answer. 2.89. What is the difference between the Domestic credit (% of GDP) of Paraguay in 2011 and the Domestic credit (% of GDP) of Poland in 2012?
Ensure brevity in your answer.  -11.18. What is the difference between the Domestic credit (% of GDP) in Paraguay in 2011 and the Domestic credit (% of GDP) in Trinidad and Tobago in 2012?
Your answer should be compact. 9.15. What is the difference between the Domestic credit (% of GDP) in Poland in 2011 and the Domestic credit (% of GDP) in Trinidad and Tobago in 2012?
Make the answer very short. 21.61. What is the average Domestic credit (% of GDP) of Georgia per year?
Provide a short and direct response. 28.1. What is the average Domestic credit (% of GDP) of Paraguay per year?
Keep it short and to the point. 27.38. What is the average Domestic credit (% of GDP) of Poland per year?
Your answer should be compact. 42.62. What is the average Domestic credit (% of GDP) of Trinidad and Tobago per year?
Provide a short and direct response. 31.56. In the year 2005, what is the difference between the Domestic credit (% of GDP) of Georgia and Domestic credit (% of GDP) of Paraguay?
Your answer should be very brief. -0.42. In the year 2005, what is the difference between the Domestic credit (% of GDP) in Georgia and Domestic credit (% of GDP) in Poland?
Your answer should be compact. -12.6. In the year 2005, what is the difference between the Domestic credit (% of GDP) of Georgia and Domestic credit (% of GDP) of Trinidad and Tobago?
Your answer should be very brief. -18.82. In the year 2005, what is the difference between the Domestic credit (% of GDP) in Paraguay and Domestic credit (% of GDP) in Poland?
Provide a short and direct response. -12.17. In the year 2005, what is the difference between the Domestic credit (% of GDP) of Paraguay and Domestic credit (% of GDP) of Trinidad and Tobago?
Offer a terse response. -18.4. In the year 2005, what is the difference between the Domestic credit (% of GDP) of Poland and Domestic credit (% of GDP) of Trinidad and Tobago?
Make the answer very short. -6.22. In the year 2006, what is the difference between the Domestic credit (% of GDP) in Georgia and Domestic credit (% of GDP) in Paraguay?
Your answer should be very brief. 4.66. In the year 2006, what is the difference between the Domestic credit (% of GDP) of Georgia and Domestic credit (% of GDP) of Poland?
Your response must be concise. -11.96. In the year 2006, what is the difference between the Domestic credit (% of GDP) in Georgia and Domestic credit (% of GDP) in Trinidad and Tobago?
Your answer should be compact. -13.32. In the year 2006, what is the difference between the Domestic credit (% of GDP) in Paraguay and Domestic credit (% of GDP) in Poland?
Give a very brief answer. -16.62. In the year 2006, what is the difference between the Domestic credit (% of GDP) of Paraguay and Domestic credit (% of GDP) of Trinidad and Tobago?
Provide a succinct answer. -17.98. In the year 2006, what is the difference between the Domestic credit (% of GDP) of Poland and Domestic credit (% of GDP) of Trinidad and Tobago?
Your answer should be very brief. -1.36. In the year 2007, what is the difference between the Domestic credit (% of GDP) of Georgia and Domestic credit (% of GDP) of Paraguay?
Give a very brief answer. 10.08. In the year 2007, what is the difference between the Domestic credit (% of GDP) in Georgia and Domestic credit (% of GDP) in Poland?
Give a very brief answer. -9.3. In the year 2007, what is the difference between the Domestic credit (% of GDP) in Georgia and Domestic credit (% of GDP) in Trinidad and Tobago?
Provide a short and direct response. -4.22. In the year 2007, what is the difference between the Domestic credit (% of GDP) of Paraguay and Domestic credit (% of GDP) of Poland?
Provide a short and direct response. -19.38. In the year 2007, what is the difference between the Domestic credit (% of GDP) of Paraguay and Domestic credit (% of GDP) of Trinidad and Tobago?
Provide a succinct answer. -14.3. In the year 2007, what is the difference between the Domestic credit (% of GDP) of Poland and Domestic credit (% of GDP) of Trinidad and Tobago?
Provide a succinct answer. 5.09. In the year 2008, what is the difference between the Domestic credit (% of GDP) in Georgia and Domestic credit (% of GDP) in Paraguay?
Provide a short and direct response. 8.09. In the year 2008, what is the difference between the Domestic credit (% of GDP) in Georgia and Domestic credit (% of GDP) in Poland?
Keep it short and to the point. -14.54. In the year 2008, what is the difference between the Domestic credit (% of GDP) in Georgia and Domestic credit (% of GDP) in Trinidad and Tobago?
Your answer should be compact. 6.34. In the year 2008, what is the difference between the Domestic credit (% of GDP) of Paraguay and Domestic credit (% of GDP) of Poland?
Make the answer very short. -22.63. In the year 2008, what is the difference between the Domestic credit (% of GDP) of Paraguay and Domestic credit (% of GDP) of Trinidad and Tobago?
Ensure brevity in your answer.  -1.75. In the year 2008, what is the difference between the Domestic credit (% of GDP) in Poland and Domestic credit (% of GDP) in Trinidad and Tobago?
Your response must be concise. 20.88. In the year 2009, what is the difference between the Domestic credit (% of GDP) in Georgia and Domestic credit (% of GDP) in Paraguay?
Your answer should be compact. 0.64. In the year 2009, what is the difference between the Domestic credit (% of GDP) of Georgia and Domestic credit (% of GDP) of Poland?
Offer a very short reply. -16.46. In the year 2009, what is the difference between the Domestic credit (% of GDP) of Georgia and Domestic credit (% of GDP) of Trinidad and Tobago?
Keep it short and to the point. -5.03. In the year 2009, what is the difference between the Domestic credit (% of GDP) in Paraguay and Domestic credit (% of GDP) in Poland?
Give a very brief answer. -17.1. In the year 2009, what is the difference between the Domestic credit (% of GDP) in Paraguay and Domestic credit (% of GDP) in Trinidad and Tobago?
Provide a succinct answer. -5.67. In the year 2009, what is the difference between the Domestic credit (% of GDP) in Poland and Domestic credit (% of GDP) in Trinidad and Tobago?
Your response must be concise. 11.44. In the year 2010, what is the difference between the Domestic credit (% of GDP) in Georgia and Domestic credit (% of GDP) in Paraguay?
Your answer should be compact. -2.76. In the year 2010, what is the difference between the Domestic credit (% of GDP) of Georgia and Domestic credit (% of GDP) of Poland?
Keep it short and to the point. -16.95. In the year 2010, what is the difference between the Domestic credit (% of GDP) of Georgia and Domestic credit (% of GDP) of Trinidad and Tobago?
Give a very brief answer. -0.68. In the year 2010, what is the difference between the Domestic credit (% of GDP) of Paraguay and Domestic credit (% of GDP) of Poland?
Give a very brief answer. -14.18. In the year 2010, what is the difference between the Domestic credit (% of GDP) in Paraguay and Domestic credit (% of GDP) in Trinidad and Tobago?
Offer a terse response. 2.08. In the year 2010, what is the difference between the Domestic credit (% of GDP) in Poland and Domestic credit (% of GDP) in Trinidad and Tobago?
Offer a terse response. 16.27. In the year 2011, what is the difference between the Domestic credit (% of GDP) of Georgia and Domestic credit (% of GDP) of Paraguay?
Offer a terse response. -6.26. In the year 2011, what is the difference between the Domestic credit (% of GDP) in Georgia and Domestic credit (% of GDP) in Poland?
Keep it short and to the point. -18.72. In the year 2011, what is the difference between the Domestic credit (% of GDP) in Georgia and Domestic credit (% of GDP) in Trinidad and Tobago?
Make the answer very short. 3.38. In the year 2011, what is the difference between the Domestic credit (% of GDP) of Paraguay and Domestic credit (% of GDP) of Poland?
Keep it short and to the point. -12.46. In the year 2011, what is the difference between the Domestic credit (% of GDP) of Paraguay and Domestic credit (% of GDP) of Trinidad and Tobago?
Keep it short and to the point. 9.63. In the year 2011, what is the difference between the Domestic credit (% of GDP) in Poland and Domestic credit (% of GDP) in Trinidad and Tobago?
Provide a succinct answer. 22.09. In the year 2012, what is the difference between the Domestic credit (% of GDP) in Georgia and Domestic credit (% of GDP) in Paraguay?
Your answer should be compact. -8.24. In the year 2012, what is the difference between the Domestic credit (% of GDP) of Georgia and Domestic credit (% of GDP) of Poland?
Your answer should be very brief. -15.68. In the year 2012, what is the difference between the Domestic credit (% of GDP) of Georgia and Domestic credit (% of GDP) of Trinidad and Tobago?
Offer a very short reply. 4.65. In the year 2012, what is the difference between the Domestic credit (% of GDP) of Paraguay and Domestic credit (% of GDP) of Poland?
Provide a short and direct response. -7.44. In the year 2012, what is the difference between the Domestic credit (% of GDP) of Paraguay and Domestic credit (% of GDP) of Trinidad and Tobago?
Your answer should be very brief. 12.88. In the year 2012, what is the difference between the Domestic credit (% of GDP) of Poland and Domestic credit (% of GDP) of Trinidad and Tobago?
Provide a succinct answer. 20.33. What is the ratio of the Domestic credit (% of GDP) of Georgia in 2005 to that in 2006?
Your answer should be very brief. 0.76. What is the ratio of the Domestic credit (% of GDP) of Paraguay in 2005 to that in 2006?
Your response must be concise. 1.03. What is the ratio of the Domestic credit (% of GDP) of Poland in 2005 to that in 2006?
Keep it short and to the point. 0.87. What is the ratio of the Domestic credit (% of GDP) of Trinidad and Tobago in 2005 to that in 2006?
Provide a short and direct response. 1.02. What is the ratio of the Domestic credit (% of GDP) of Georgia in 2005 to that in 2007?
Offer a very short reply. 0.53. What is the ratio of the Domestic credit (% of GDP) in Paraguay in 2005 to that in 2007?
Ensure brevity in your answer.  0.85. What is the ratio of the Domestic credit (% of GDP) in Poland in 2005 to that in 2007?
Offer a very short reply. 0.73. What is the ratio of the Domestic credit (% of GDP) in Trinidad and Tobago in 2005 to that in 2007?
Provide a short and direct response. 1.04. What is the ratio of the Domestic credit (% of GDP) in Georgia in 2005 to that in 2008?
Make the answer very short. 0.44. What is the ratio of the Domestic credit (% of GDP) of Paraguay in 2005 to that in 2008?
Provide a short and direct response. 0.6. What is the ratio of the Domestic credit (% of GDP) of Poland in 2005 to that in 2008?
Your answer should be very brief. 0.57. What is the ratio of the Domestic credit (% of GDP) of Trinidad and Tobago in 2005 to that in 2008?
Provide a succinct answer. 1.25. What is the ratio of the Domestic credit (% of GDP) of Georgia in 2005 to that in 2009?
Provide a short and direct response. 0.47. What is the ratio of the Domestic credit (% of GDP) in Paraguay in 2005 to that in 2009?
Provide a short and direct response. 0.5. What is the ratio of the Domestic credit (% of GDP) in Poland in 2005 to that in 2009?
Your response must be concise. 0.58. What is the ratio of the Domestic credit (% of GDP) of Trinidad and Tobago in 2005 to that in 2009?
Ensure brevity in your answer.  0.93. What is the ratio of the Domestic credit (% of GDP) of Georgia in 2005 to that in 2010?
Provide a succinct answer. 0.46. What is the ratio of the Domestic credit (% of GDP) of Paraguay in 2005 to that in 2010?
Keep it short and to the point. 0.44. What is the ratio of the Domestic credit (% of GDP) of Poland in 2005 to that in 2010?
Provide a succinct answer. 0.56. What is the ratio of the Domestic credit (% of GDP) of Trinidad and Tobago in 2005 to that in 2010?
Offer a very short reply. 1.03. What is the ratio of the Domestic credit (% of GDP) in Georgia in 2005 to that in 2011?
Make the answer very short. 0.45. What is the ratio of the Domestic credit (% of GDP) of Paraguay in 2005 to that in 2011?
Your response must be concise. 0.39. What is the ratio of the Domestic credit (% of GDP) of Poland in 2005 to that in 2011?
Make the answer very short. 0.53. What is the ratio of the Domestic credit (% of GDP) of Georgia in 2005 to that in 2012?
Your answer should be compact. 0.43. What is the ratio of the Domestic credit (% of GDP) in Paraguay in 2005 to that in 2012?
Provide a short and direct response. 0.35. What is the ratio of the Domestic credit (% of GDP) of Poland in 2005 to that in 2012?
Keep it short and to the point. 0.54. What is the ratio of the Domestic credit (% of GDP) in Trinidad and Tobago in 2005 to that in 2012?
Keep it short and to the point. 1.12. What is the ratio of the Domestic credit (% of GDP) in Georgia in 2006 to that in 2007?
Your answer should be very brief. 0.7. What is the ratio of the Domestic credit (% of GDP) of Paraguay in 2006 to that in 2007?
Your answer should be compact. 0.83. What is the ratio of the Domestic credit (% of GDP) in Poland in 2006 to that in 2007?
Ensure brevity in your answer.  0.84. What is the ratio of the Domestic credit (% of GDP) of Georgia in 2006 to that in 2008?
Provide a succinct answer. 0.59. What is the ratio of the Domestic credit (% of GDP) of Paraguay in 2006 to that in 2008?
Your response must be concise. 0.59. What is the ratio of the Domestic credit (% of GDP) of Poland in 2006 to that in 2008?
Offer a very short reply. 0.66. What is the ratio of the Domestic credit (% of GDP) in Trinidad and Tobago in 2006 to that in 2008?
Provide a short and direct response. 1.22. What is the ratio of the Domestic credit (% of GDP) of Georgia in 2006 to that in 2009?
Make the answer very short. 0.63. What is the ratio of the Domestic credit (% of GDP) in Paraguay in 2006 to that in 2009?
Offer a very short reply. 0.49. What is the ratio of the Domestic credit (% of GDP) in Poland in 2006 to that in 2009?
Offer a terse response. 0.66. What is the ratio of the Domestic credit (% of GDP) in Trinidad and Tobago in 2006 to that in 2009?
Keep it short and to the point. 0.91. What is the ratio of the Domestic credit (% of GDP) of Georgia in 2006 to that in 2010?
Offer a very short reply. 0.61. What is the ratio of the Domestic credit (% of GDP) of Paraguay in 2006 to that in 2010?
Your answer should be very brief. 0.43. What is the ratio of the Domestic credit (% of GDP) in Poland in 2006 to that in 2010?
Your response must be concise. 0.64. What is the ratio of the Domestic credit (% of GDP) in Trinidad and Tobago in 2006 to that in 2010?
Offer a very short reply. 1.01. What is the ratio of the Domestic credit (% of GDP) of Georgia in 2006 to that in 2011?
Offer a very short reply. 0.59. What is the ratio of the Domestic credit (% of GDP) of Paraguay in 2006 to that in 2011?
Make the answer very short. 0.38. What is the ratio of the Domestic credit (% of GDP) in Poland in 2006 to that in 2011?
Offer a terse response. 0.61. What is the ratio of the Domestic credit (% of GDP) of Trinidad and Tobago in 2006 to that in 2011?
Your answer should be very brief. 1.12. What is the ratio of the Domestic credit (% of GDP) in Georgia in 2006 to that in 2012?
Your answer should be compact. 0.56. What is the ratio of the Domestic credit (% of GDP) of Paraguay in 2006 to that in 2012?
Offer a terse response. 0.34. What is the ratio of the Domestic credit (% of GDP) of Poland in 2006 to that in 2012?
Your answer should be very brief. 0.63. What is the ratio of the Domestic credit (% of GDP) of Trinidad and Tobago in 2006 to that in 2012?
Your answer should be very brief. 1.1. What is the ratio of the Domestic credit (% of GDP) of Georgia in 2007 to that in 2008?
Your response must be concise. 0.84. What is the ratio of the Domestic credit (% of GDP) in Paraguay in 2007 to that in 2008?
Your answer should be very brief. 0.71. What is the ratio of the Domestic credit (% of GDP) of Poland in 2007 to that in 2008?
Your answer should be compact. 0.78. What is the ratio of the Domestic credit (% of GDP) of Trinidad and Tobago in 2007 to that in 2008?
Offer a terse response. 1.2. What is the ratio of the Domestic credit (% of GDP) in Georgia in 2007 to that in 2009?
Provide a short and direct response. 0.9. What is the ratio of the Domestic credit (% of GDP) of Paraguay in 2007 to that in 2009?
Your answer should be very brief. 0.59. What is the ratio of the Domestic credit (% of GDP) of Poland in 2007 to that in 2009?
Make the answer very short. 0.78. What is the ratio of the Domestic credit (% of GDP) of Trinidad and Tobago in 2007 to that in 2009?
Make the answer very short. 0.89. What is the ratio of the Domestic credit (% of GDP) of Georgia in 2007 to that in 2010?
Your response must be concise. 0.88. What is the ratio of the Domestic credit (% of GDP) in Paraguay in 2007 to that in 2010?
Provide a succinct answer. 0.51. What is the ratio of the Domestic credit (% of GDP) in Poland in 2007 to that in 2010?
Give a very brief answer. 0.76. What is the ratio of the Domestic credit (% of GDP) of Trinidad and Tobago in 2007 to that in 2010?
Provide a short and direct response. 0.99. What is the ratio of the Domestic credit (% of GDP) in Georgia in 2007 to that in 2011?
Ensure brevity in your answer.  0.85. What is the ratio of the Domestic credit (% of GDP) of Paraguay in 2007 to that in 2011?
Your answer should be compact. 0.46. What is the ratio of the Domestic credit (% of GDP) of Poland in 2007 to that in 2011?
Keep it short and to the point. 0.72. What is the ratio of the Domestic credit (% of GDP) of Trinidad and Tobago in 2007 to that in 2011?
Keep it short and to the point. 1.09. What is the ratio of the Domestic credit (% of GDP) of Georgia in 2007 to that in 2012?
Provide a succinct answer. 0.81. What is the ratio of the Domestic credit (% of GDP) of Paraguay in 2007 to that in 2012?
Your answer should be compact. 0.42. What is the ratio of the Domestic credit (% of GDP) in Poland in 2007 to that in 2012?
Your response must be concise. 0.74. What is the ratio of the Domestic credit (% of GDP) of Trinidad and Tobago in 2007 to that in 2012?
Your response must be concise. 1.08. What is the ratio of the Domestic credit (% of GDP) in Georgia in 2008 to that in 2009?
Offer a very short reply. 1.07. What is the ratio of the Domestic credit (% of GDP) in Paraguay in 2008 to that in 2009?
Provide a succinct answer. 0.82. What is the ratio of the Domestic credit (% of GDP) in Poland in 2008 to that in 2009?
Provide a succinct answer. 1. What is the ratio of the Domestic credit (% of GDP) of Trinidad and Tobago in 2008 to that in 2009?
Ensure brevity in your answer.  0.74. What is the ratio of the Domestic credit (% of GDP) in Georgia in 2008 to that in 2010?
Make the answer very short. 1.04. What is the ratio of the Domestic credit (% of GDP) in Paraguay in 2008 to that in 2010?
Offer a very short reply. 0.72. What is the ratio of the Domestic credit (% of GDP) of Trinidad and Tobago in 2008 to that in 2010?
Your response must be concise. 0.82. What is the ratio of the Domestic credit (% of GDP) of Georgia in 2008 to that in 2011?
Ensure brevity in your answer.  1.01. What is the ratio of the Domestic credit (% of GDP) in Paraguay in 2008 to that in 2011?
Provide a short and direct response. 0.64. What is the ratio of the Domestic credit (% of GDP) of Poland in 2008 to that in 2011?
Keep it short and to the point. 0.93. What is the ratio of the Domestic credit (% of GDP) of Trinidad and Tobago in 2008 to that in 2011?
Offer a very short reply. 0.91. What is the ratio of the Domestic credit (% of GDP) of Georgia in 2008 to that in 2012?
Make the answer very short. 0.96. What is the ratio of the Domestic credit (% of GDP) in Paraguay in 2008 to that in 2012?
Your answer should be very brief. 0.58. What is the ratio of the Domestic credit (% of GDP) of Poland in 2008 to that in 2012?
Give a very brief answer. 0.95. What is the ratio of the Domestic credit (% of GDP) of Trinidad and Tobago in 2008 to that in 2012?
Ensure brevity in your answer.  0.9. What is the ratio of the Domestic credit (% of GDP) in Georgia in 2009 to that in 2010?
Your answer should be compact. 0.97. What is the ratio of the Domestic credit (% of GDP) of Paraguay in 2009 to that in 2010?
Offer a terse response. 0.88. What is the ratio of the Domestic credit (% of GDP) in Poland in 2009 to that in 2010?
Offer a terse response. 0.97. What is the ratio of the Domestic credit (% of GDP) in Trinidad and Tobago in 2009 to that in 2010?
Provide a short and direct response. 1.11. What is the ratio of the Domestic credit (% of GDP) in Georgia in 2009 to that in 2011?
Your answer should be very brief. 0.95. What is the ratio of the Domestic credit (% of GDP) of Poland in 2009 to that in 2011?
Your response must be concise. 0.92. What is the ratio of the Domestic credit (% of GDP) of Trinidad and Tobago in 2009 to that in 2011?
Provide a short and direct response. 1.23. What is the ratio of the Domestic credit (% of GDP) in Georgia in 2009 to that in 2012?
Offer a terse response. 0.9. What is the ratio of the Domestic credit (% of GDP) of Paraguay in 2009 to that in 2012?
Offer a terse response. 0.71. What is the ratio of the Domestic credit (% of GDP) in Poland in 2009 to that in 2012?
Offer a very short reply. 0.95. What is the ratio of the Domestic credit (% of GDP) in Trinidad and Tobago in 2009 to that in 2012?
Make the answer very short. 1.21. What is the ratio of the Domestic credit (% of GDP) in Georgia in 2010 to that in 2011?
Offer a very short reply. 0.97. What is the ratio of the Domestic credit (% of GDP) of Paraguay in 2010 to that in 2011?
Ensure brevity in your answer.  0.89. What is the ratio of the Domestic credit (% of GDP) of Poland in 2010 to that in 2011?
Ensure brevity in your answer.  0.95. What is the ratio of the Domestic credit (% of GDP) in Trinidad and Tobago in 2010 to that in 2011?
Ensure brevity in your answer.  1.11. What is the ratio of the Domestic credit (% of GDP) in Georgia in 2010 to that in 2012?
Ensure brevity in your answer.  0.92. What is the ratio of the Domestic credit (% of GDP) in Paraguay in 2010 to that in 2012?
Your response must be concise. 0.81. What is the ratio of the Domestic credit (% of GDP) in Poland in 2010 to that in 2012?
Ensure brevity in your answer.  0.97. What is the ratio of the Domestic credit (% of GDP) of Trinidad and Tobago in 2010 to that in 2012?
Give a very brief answer. 1.09. What is the ratio of the Domestic credit (% of GDP) of Georgia in 2011 to that in 2012?
Keep it short and to the point. 0.95. What is the ratio of the Domestic credit (% of GDP) in Paraguay in 2011 to that in 2012?
Your answer should be very brief. 0.91. What is the ratio of the Domestic credit (% of GDP) in Poland in 2011 to that in 2012?
Provide a short and direct response. 1.03. What is the ratio of the Domestic credit (% of GDP) of Trinidad and Tobago in 2011 to that in 2012?
Offer a terse response. 0.98. What is the difference between the highest and the second highest Domestic credit (% of GDP) in Georgia?
Give a very brief answer. 1.39. What is the difference between the highest and the second highest Domestic credit (% of GDP) of Paraguay?
Your response must be concise. 3.74. What is the difference between the highest and the second highest Domestic credit (% of GDP) in Poland?
Offer a very short reply. 1.28. What is the difference between the highest and the second highest Domestic credit (% of GDP) in Trinidad and Tobago?
Offer a very short reply. 2.46. What is the difference between the highest and the lowest Domestic credit (% of GDP) of Georgia?
Offer a very short reply. 19.76. What is the difference between the highest and the lowest Domestic credit (% of GDP) of Paraguay?
Your answer should be very brief. 27.96. What is the difference between the highest and the lowest Domestic credit (% of GDP) in Poland?
Your answer should be very brief. 24.13. What is the difference between the highest and the lowest Domestic credit (% of GDP) of Trinidad and Tobago?
Provide a succinct answer. 9.25. 